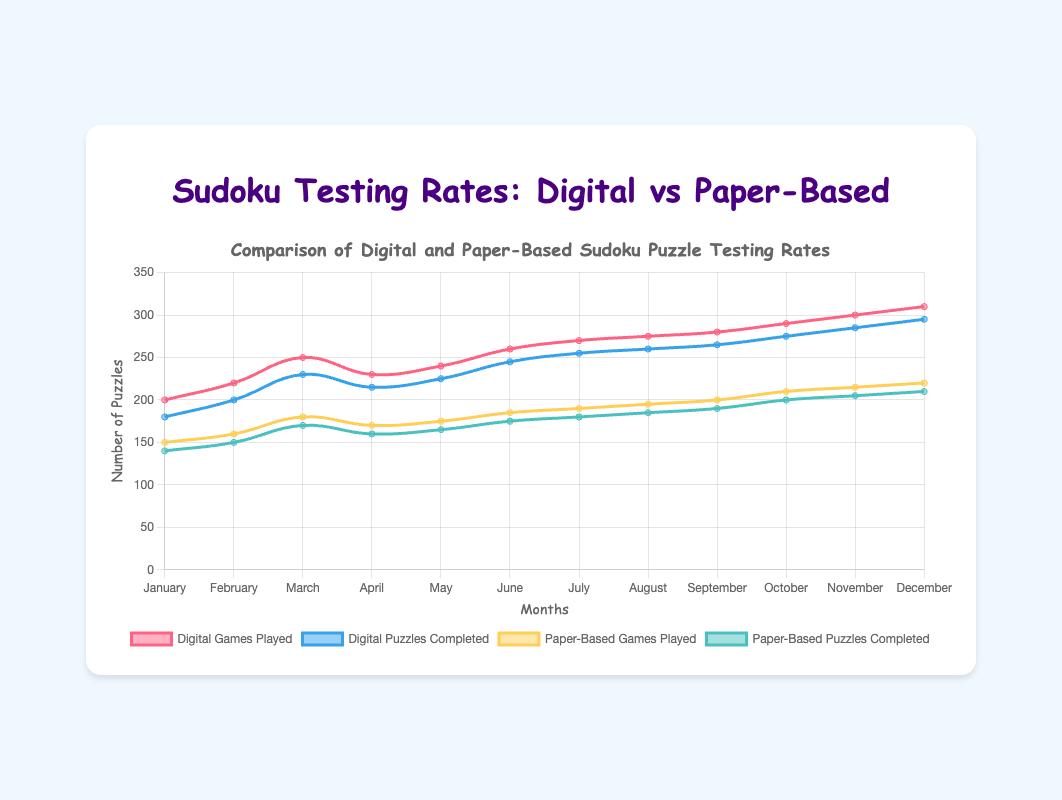Which month had the highest number of digital games played? To find the month with the highest number of digital games played, look for the peak value in the 'Digital Games Played' dataset. The peak is in December, with 310 games played.
Answer: December How many more digital puzzles were completed in June compared to paper-based puzzles in the same month? First, find the number of digital puzzles completed in June (245) and paper-based puzzles completed in June (175). Then, subtract the paper-based number from the digital number: 245 - 175 = 70.
Answer: 70 What's the total number of digital puzzles completed from January to June? Sum the values of digital puzzles completed from January to June: 180 + 200 + 230 + 215 + 225 + 245 = 1295.
Answer: 1295 Compare the number of games played digitally and on paper, in September. Which is higher and by how much? In September, the number of digital games played is 280, and paper-based games played is 200. The digital games played are higher. Subtract the number of paper-based games from digital: 280 - 200 = 80.
Answer: Digital, 80 What is the average number of paper-based puzzles completed per month? Sum all the values of paper-based puzzles completed and divide by the number of months: (140 + 150 + 170 + 160 + 165 + 175 + 180 + 185 + 190 + 200 + 205 + 210) / 12 = 2130 / 12 = 177.5.
Answer: 177.5 In which month were the digital games played and puzzles completed closest to each other, and what is the difference? Calculate the difference between digital games played and puzzles completed for each month. The smallest difference is in April with (230 - 215 = 15).
Answer: April, 15 Which category shows a higher increase in games played from January to December, digital or paper-based? First, calculate the increase for digital (310 - 200 = 110) and for paper-based (220 - 150 = 70). Digital shows a higher increase.
Answer: Digital What's the largest difference between games played and puzzles completed within a single month for paper-based testing? Calculate the difference for each month and find the largest one: January (10), February (10), March (10), April (10), May (10), June (10), July (10), August (10), September (10), October (10), November (10), December (10). All differences are 10.
Answer: 10 Compare the total digital games played to the total paper-based games played for the year. Which is greater and by how much? Sum the total games played digitally (200 + 220 + 250 + 230 + 240 + 260 + 270 + 275 + 280 + 290 + 300 + 310 = 3125) and total games played on paper (150 + 160 + 180 + 170 + 175 + 185 + 190 + 195 + 200 + 210 + 215 + 220 = 2250). Digital is greater by 3125 - 2250 = 875.
Answer: Digital, 875 